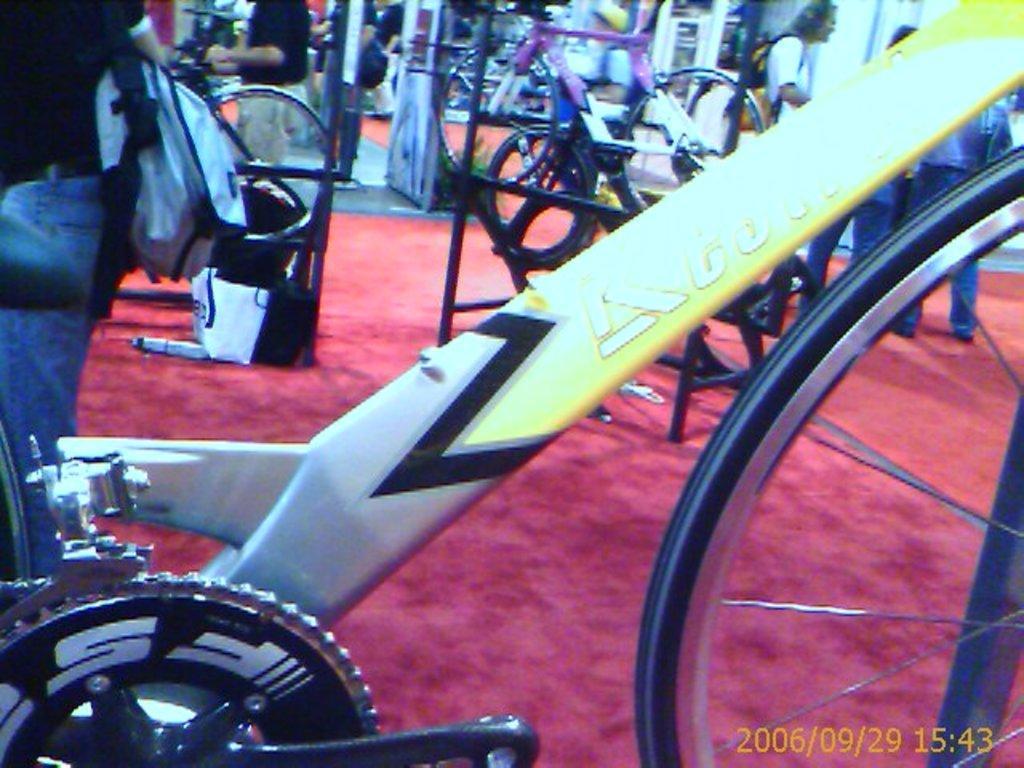Can you describe this image briefly? In this image, we can see a rod, crank wheel. On the right side, there is a wheel. Background we can see few bicycles, peoples. Few are wearing bags. Right side bottom of the image, we can see a watermark. It represents date and time. 